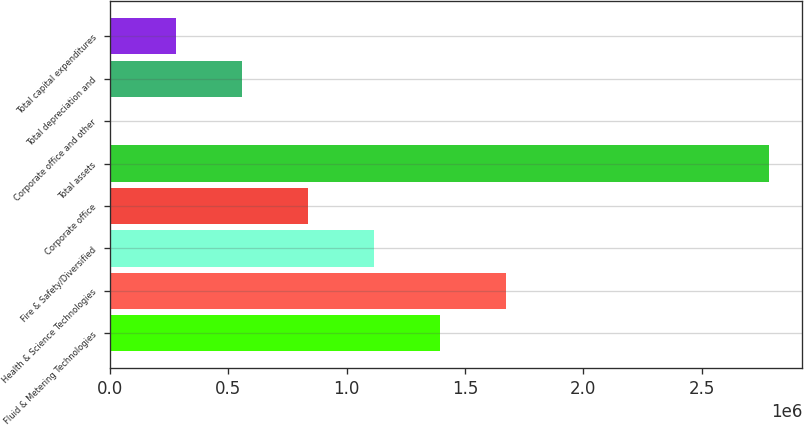<chart> <loc_0><loc_0><loc_500><loc_500><bar_chart><fcel>Fluid & Metering Technologies<fcel>Health & Science Technologies<fcel>Fire & Safety/Diversified<fcel>Corporate office<fcel>Total assets<fcel>Corporate office and other<fcel>Total depreciation and<fcel>Total capital expenditures<nl><fcel>1.39349e+06<fcel>1.67187e+06<fcel>1.11511e+06<fcel>836728<fcel>2.78539e+06<fcel>1587<fcel>558348<fcel>279967<nl></chart> 